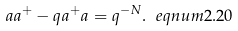Convert formula to latex. <formula><loc_0><loc_0><loc_500><loc_500>a a ^ { + } - q a ^ { + } a = q ^ { - N } . \ e q n u m { 2 . 2 0 }</formula> 